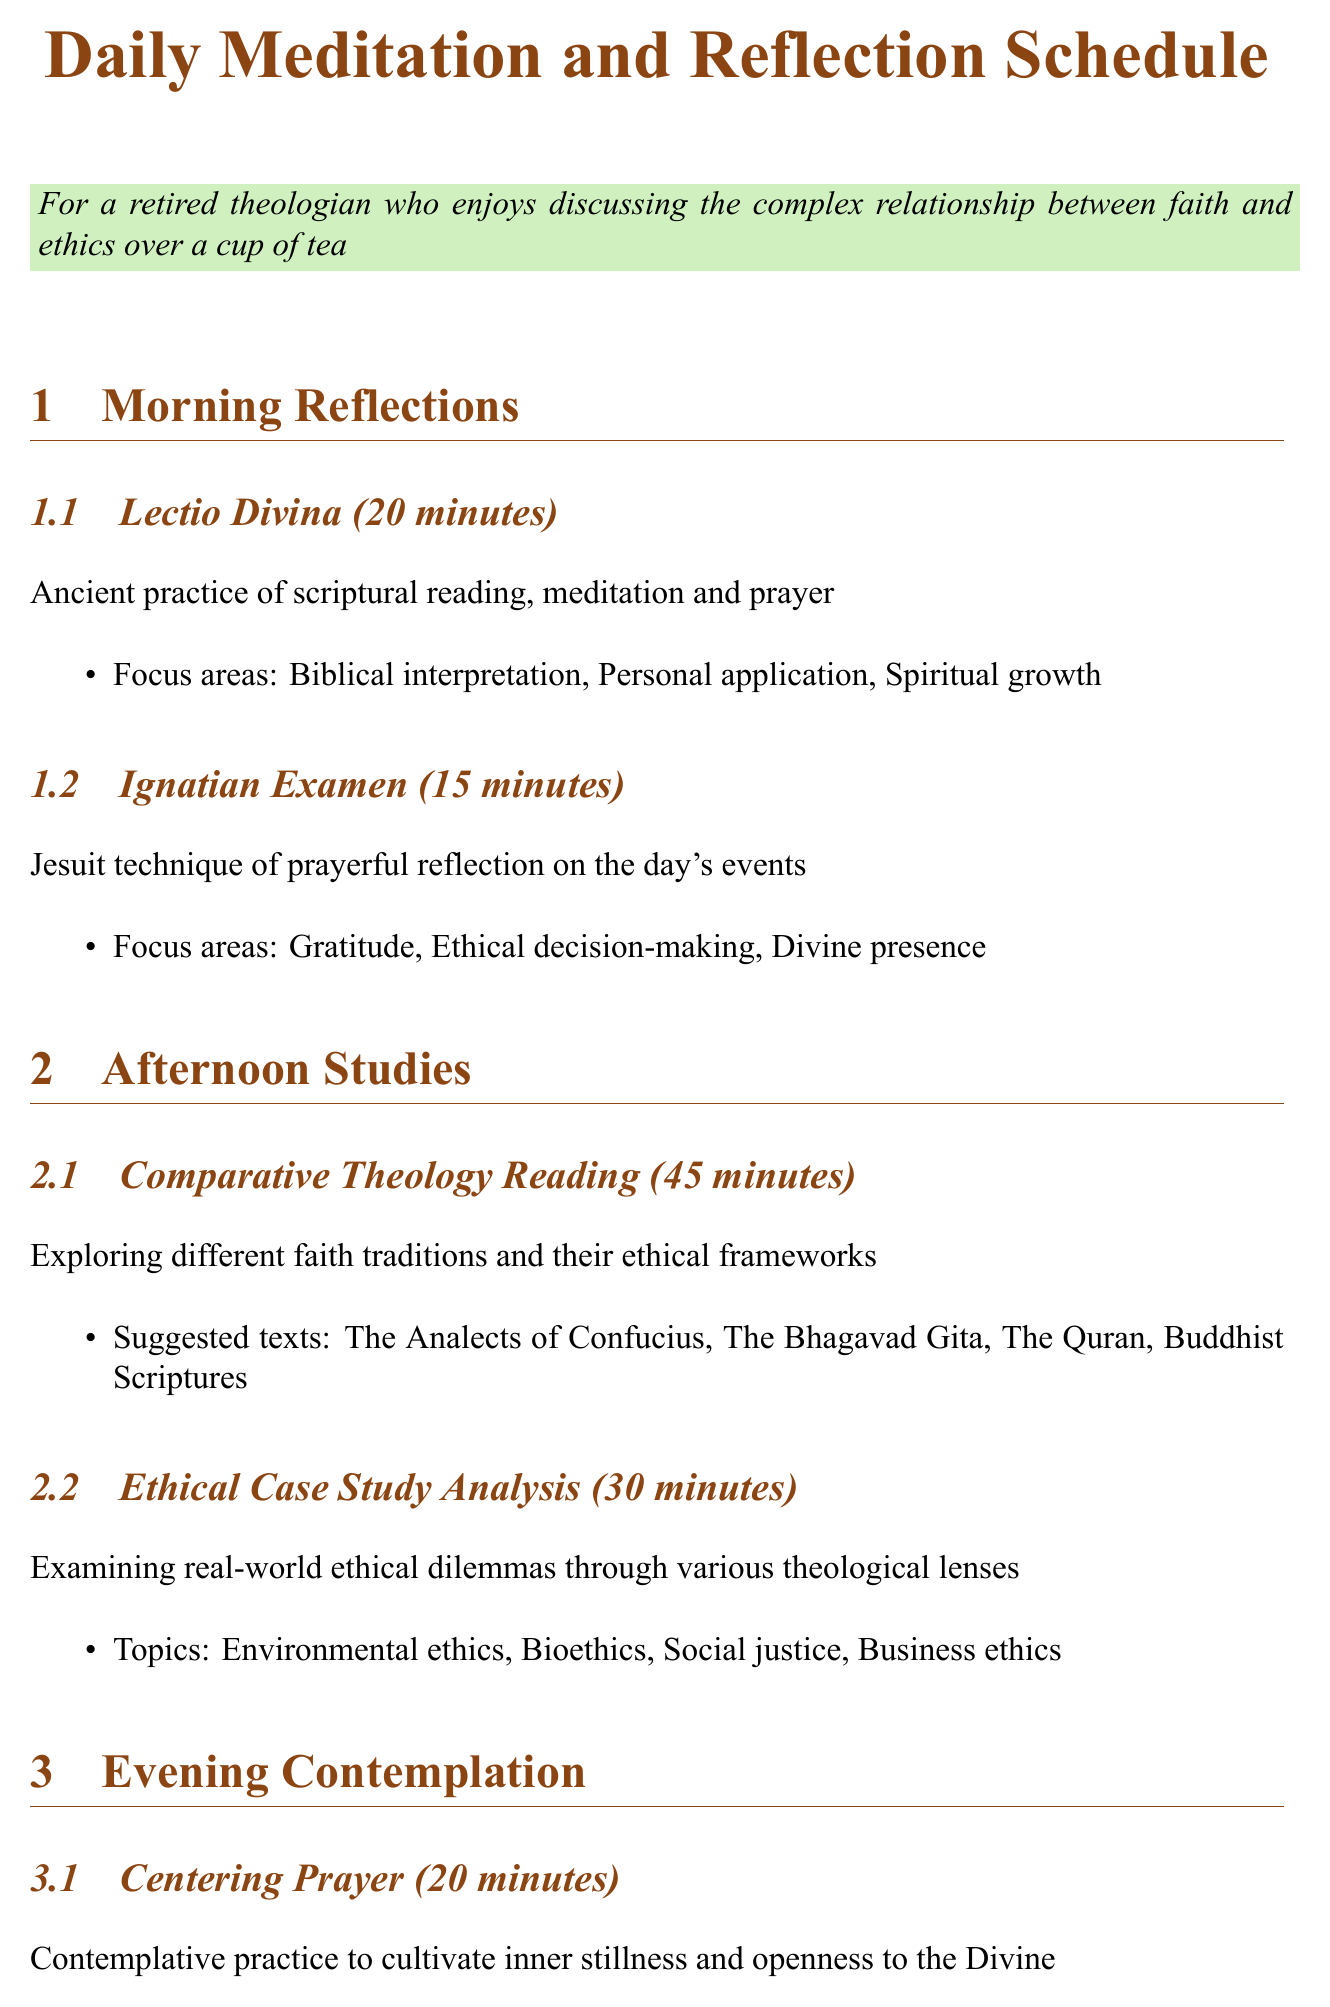What is the duration of Lectio Divina? The document states that Lectio Divina lasts for 20 minutes.
Answer: 20 minutes What is the main focus of Ignatian Examen? The Ignatian Examen focuses on gratitude, ethical decision-making, and divine presence according to the document.
Answer: Gratitude, ethical decision-making, divine presence How long is the weekly Interfaith Dialogue Group session? The Interfaith Dialogue Group session is 90 minutes long as mentioned in the document.
Answer: 90 minutes What activity is suggested for the Silent Retreat Day? The document lists contemplative walking as one of the activities for the Silent Retreat Day.
Answer: Contemplative walking What ethical topic is explored in the Ethical Living Workshop? The document mentions "stewardship of resources and environmental responsibility" as one of the topics.
Answer: Stewardship of resources and environmental responsibility What is the frequency of the Volunteer Work at Local Soup Kitchen? According to the document, the Volunteer Work at the Local Soup Kitchen occurs once a week.
Answer: Once a week How many minutes is allocated for Theological Journaling? The Theological Journaling session is allotted 25 minutes as per the document.
Answer: 25 minutes What reflection points are considered in the Volunteer Work at Local Soup Kitchen? The document states that the reflection points include "the theological significance of serving others."
Answer: The theological significance of serving others 